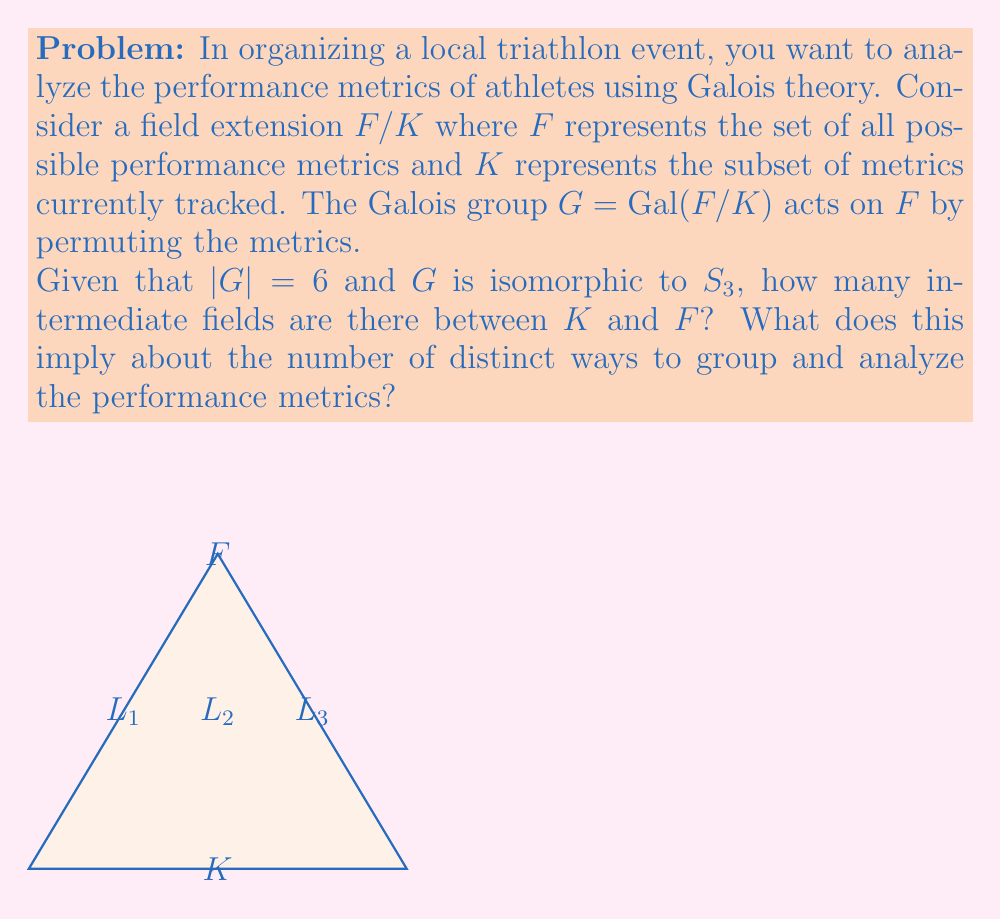Can you answer this question? To solve this problem, we'll use the Fundamental Theorem of Galois Theory and properties of $S_3$.

1) The Fundamental Theorem of Galois Theory states that there is a one-to-one correspondence between intermediate fields of $F/K$ and subgroups of $G = Gal(F/K)$.

2) $G$ is isomorphic to $S_3$, the symmetric group on 3 elements. We need to find the number of subgroups of $S_3$.

3) $S_3$ has the following subgroups:
   - The trivial subgroup $\{e\}$
   - Three subgroups of order 2 (corresponding to the three transpositions)
   - One subgroup of order 3 (the alternating group $A_3$)
   - The full group $S_3$ itself

4) In total, there are 6 subgroups of $S_3$.

5) By the Fundamental Theorem of Galois Theory, this means there are 6 intermediate fields between $K$ and $F$, including $K$ and $F$ themselves.

6) For the triathlon context, this implies that there are 4 non-trivial ways to group and analyze the performance metrics between the basic set $K$ and the full set $F$.

These groupings could correspond to different aspects of triathlon performance, such as:
- Swimming metrics
- Cycling metrics
- Running metrics
- Combined endurance metrics
Answer: 6 intermediate fields; 4 non-trivial groupings of performance metrics 